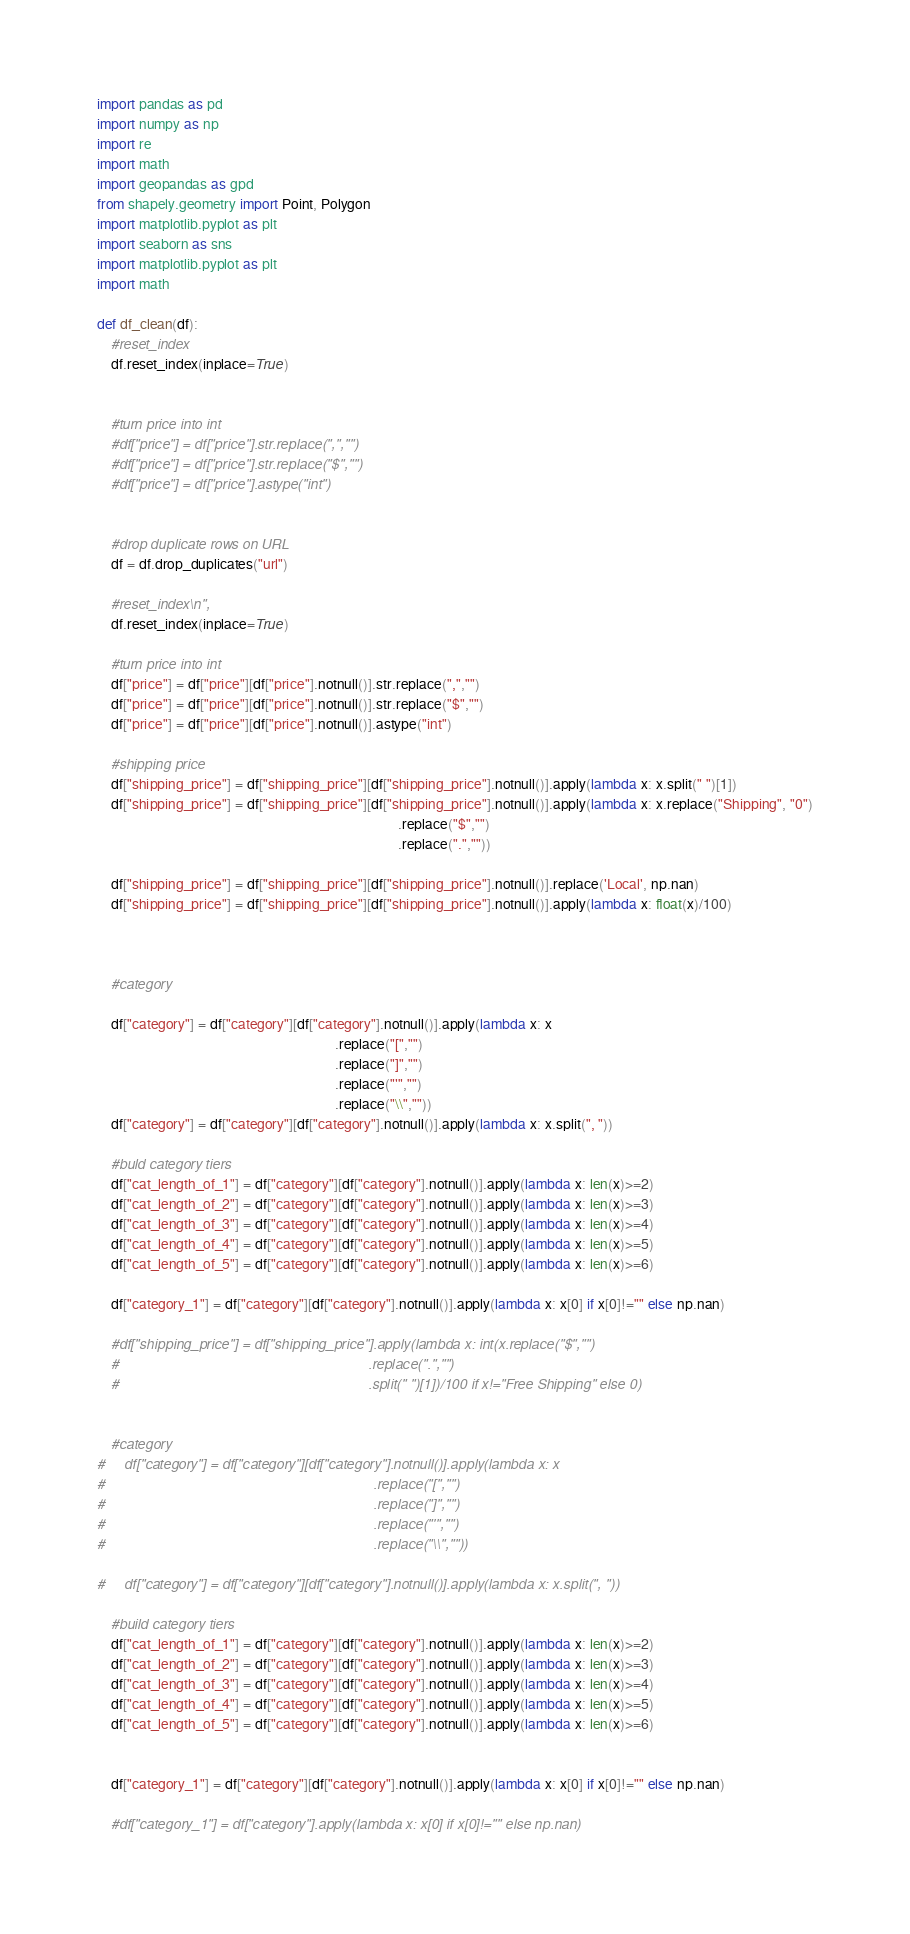<code> <loc_0><loc_0><loc_500><loc_500><_Python_>import pandas as pd
import numpy as np
import re
import math
import geopandas as gpd
from shapely.geometry import Point, Polygon
import matplotlib.pyplot as plt
import seaborn as sns
import matplotlib.pyplot as plt
import math

def df_clean(df):
    #reset_index
    df.reset_index(inplace=True)


    #turn price into int
    #df["price"] = df["price"].str.replace(",","")
    #df["price"] = df["price"].str.replace("$","")
    #df["price"] = df["price"].astype("int")

    
    #drop duplicate rows on URL
    df = df.drop_duplicates("url")
    
    #reset_index\n",
    df.reset_index(inplace=True)
   
    #turn price into int
    df["price"] = df["price"][df["price"].notnull()].str.replace(",","")
    df["price"] = df["price"][df["price"].notnull()].str.replace("$","")
    df["price"] = df["price"][df["price"].notnull()].astype("int")
    
    #shipping price
    df["shipping_price"] = df["shipping_price"][df["shipping_price"].notnull()].apply(lambda x: x.split(" ")[1])
    df["shipping_price"] = df["shipping_price"][df["shipping_price"].notnull()].apply(lambda x: x.replace("Shipping", "0")
                                                                                      .replace("$","")
                                                                                      .replace(".",""))
                                                                                     
    df["shipping_price"] = df["shipping_price"][df["shipping_price"].notnull()].replace('Local', np.nan)
    df["shipping_price"] = df["shipping_price"][df["shipping_price"].notnull()].apply(lambda x: float(x)/100)



    #category

    df["category"] = df["category"][df["category"].notnull()].apply(lambda x: x
                                                                    .replace("[","")
                                                                    .replace("]","")
                                                                    .replace("'","")
                                                                    .replace("\\",""))
    df["category"] = df["category"][df["category"].notnull()].apply(lambda x: x.split(", "))
   
    #buld category tiers
    df["cat_length_of_1"] = df["category"][df["category"].notnull()].apply(lambda x: len(x)>=2)
    df["cat_length_of_2"] = df["category"][df["category"].notnull()].apply(lambda x: len(x)>=3)
    df["cat_length_of_3"] = df["category"][df["category"].notnull()].apply(lambda x: len(x)>=4)
    df["cat_length_of_4"] = df["category"][df["category"].notnull()].apply(lambda x: len(x)>=5)
    df["cat_length_of_5"] = df["category"][df["category"].notnull()].apply(lambda x: len(x)>=6)

    df["category_1"] = df["category"][df["category"].notnull()].apply(lambda x: x[0] if x[0]!="" else np.nan)

    #df["shipping_price"] = df["shipping_price"].apply(lambda x: int(x.replace("$","")
    #                                                                .replace(".","")
    #                                                                .split(" ")[1])/100 if x!="Free Shipping" else 0)


    #category
#     df["category"] = df["category"][df["category"].notnull()].apply(lambda x: x
#                                                                     .replace("[","")
#                                                                     .replace("]","")
#                                                                     .replace("'","")
#                                                                     .replace("\\",""))
                                                                             
#     df["category"] = df["category"][df["category"].notnull()].apply(lambda x: x.split(", "))
                                                                                                                                        
    #build category tiers
    df["cat_length_of_1"] = df["category"][df["category"].notnull()].apply(lambda x: len(x)>=2)
    df["cat_length_of_2"] = df["category"][df["category"].notnull()].apply(lambda x: len(x)>=3)
    df["cat_length_of_3"] = df["category"][df["category"].notnull()].apply(lambda x: len(x)>=4)
    df["cat_length_of_4"] = df["category"][df["category"].notnull()].apply(lambda x: len(x)>=5)
    df["cat_length_of_5"] = df["category"][df["category"].notnull()].apply(lambda x: len(x)>=6)


    df["category_1"] = df["category"][df["category"].notnull()].apply(lambda x: x[0] if x[0]!="" else np.nan)

    #df["category_1"] = df["category"].apply(lambda x: x[0] if x[0]!="" else np.nan)
</code> 